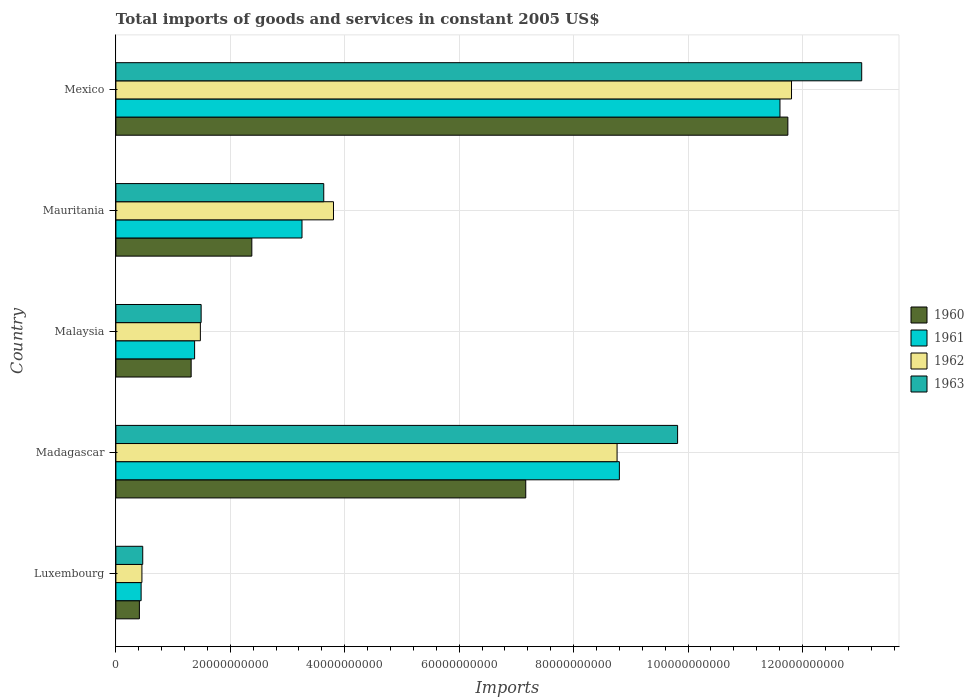How many groups of bars are there?
Ensure brevity in your answer.  5. Are the number of bars on each tick of the Y-axis equal?
Offer a very short reply. Yes. How many bars are there on the 3rd tick from the top?
Offer a terse response. 4. How many bars are there on the 1st tick from the bottom?
Offer a terse response. 4. What is the label of the 5th group of bars from the top?
Your answer should be compact. Luxembourg. In how many cases, is the number of bars for a given country not equal to the number of legend labels?
Provide a short and direct response. 0. What is the total imports of goods and services in 1960 in Malaysia?
Offer a terse response. 1.32e+1. Across all countries, what is the maximum total imports of goods and services in 1960?
Offer a very short reply. 1.17e+11. Across all countries, what is the minimum total imports of goods and services in 1963?
Give a very brief answer. 4.69e+09. In which country was the total imports of goods and services in 1963 minimum?
Provide a short and direct response. Luxembourg. What is the total total imports of goods and services in 1963 in the graph?
Make the answer very short. 2.84e+11. What is the difference between the total imports of goods and services in 1962 in Luxembourg and that in Malaysia?
Your answer should be very brief. -1.02e+1. What is the difference between the total imports of goods and services in 1961 in Mauritania and the total imports of goods and services in 1963 in Luxembourg?
Offer a terse response. 2.78e+1. What is the average total imports of goods and services in 1963 per country?
Ensure brevity in your answer.  5.69e+1. What is the difference between the total imports of goods and services in 1961 and total imports of goods and services in 1962 in Luxembourg?
Provide a short and direct response. -1.40e+08. What is the ratio of the total imports of goods and services in 1962 in Madagascar to that in Malaysia?
Provide a short and direct response. 5.93. Is the difference between the total imports of goods and services in 1961 in Luxembourg and Mexico greater than the difference between the total imports of goods and services in 1962 in Luxembourg and Mexico?
Give a very brief answer. Yes. What is the difference between the highest and the second highest total imports of goods and services in 1963?
Offer a very short reply. 3.22e+1. What is the difference between the highest and the lowest total imports of goods and services in 1962?
Provide a succinct answer. 1.14e+11. In how many countries, is the total imports of goods and services in 1963 greater than the average total imports of goods and services in 1963 taken over all countries?
Provide a succinct answer. 2. What does the 4th bar from the top in Mexico represents?
Offer a terse response. 1960. Are all the bars in the graph horizontal?
Your response must be concise. Yes. What is the difference between two consecutive major ticks on the X-axis?
Provide a short and direct response. 2.00e+1. Are the values on the major ticks of X-axis written in scientific E-notation?
Give a very brief answer. No. Where does the legend appear in the graph?
Ensure brevity in your answer.  Center right. What is the title of the graph?
Offer a very short reply. Total imports of goods and services in constant 2005 US$. Does "2001" appear as one of the legend labels in the graph?
Offer a terse response. No. What is the label or title of the X-axis?
Offer a very short reply. Imports. What is the Imports of 1960 in Luxembourg?
Keep it short and to the point. 4.11e+09. What is the Imports in 1961 in Luxembourg?
Give a very brief answer. 4.41e+09. What is the Imports of 1962 in Luxembourg?
Your answer should be compact. 4.55e+09. What is the Imports in 1963 in Luxembourg?
Make the answer very short. 4.69e+09. What is the Imports of 1960 in Madagascar?
Your answer should be compact. 7.16e+1. What is the Imports of 1961 in Madagascar?
Your response must be concise. 8.80e+1. What is the Imports in 1962 in Madagascar?
Provide a short and direct response. 8.76e+1. What is the Imports of 1963 in Madagascar?
Your response must be concise. 9.82e+1. What is the Imports of 1960 in Malaysia?
Ensure brevity in your answer.  1.32e+1. What is the Imports in 1961 in Malaysia?
Give a very brief answer. 1.38e+1. What is the Imports in 1962 in Malaysia?
Offer a terse response. 1.48e+1. What is the Imports of 1963 in Malaysia?
Your answer should be compact. 1.49e+1. What is the Imports in 1960 in Mauritania?
Offer a terse response. 2.38e+1. What is the Imports in 1961 in Mauritania?
Your answer should be compact. 3.25e+1. What is the Imports in 1962 in Mauritania?
Give a very brief answer. 3.80e+1. What is the Imports of 1963 in Mauritania?
Your answer should be compact. 3.63e+1. What is the Imports of 1960 in Mexico?
Keep it short and to the point. 1.17e+11. What is the Imports of 1961 in Mexico?
Make the answer very short. 1.16e+11. What is the Imports in 1962 in Mexico?
Give a very brief answer. 1.18e+11. What is the Imports of 1963 in Mexico?
Your answer should be very brief. 1.30e+11. Across all countries, what is the maximum Imports in 1960?
Your response must be concise. 1.17e+11. Across all countries, what is the maximum Imports of 1961?
Your response must be concise. 1.16e+11. Across all countries, what is the maximum Imports of 1962?
Offer a terse response. 1.18e+11. Across all countries, what is the maximum Imports of 1963?
Your answer should be very brief. 1.30e+11. Across all countries, what is the minimum Imports of 1960?
Your response must be concise. 4.11e+09. Across all countries, what is the minimum Imports in 1961?
Keep it short and to the point. 4.41e+09. Across all countries, what is the minimum Imports in 1962?
Your answer should be very brief. 4.55e+09. Across all countries, what is the minimum Imports of 1963?
Give a very brief answer. 4.69e+09. What is the total Imports of 1960 in the graph?
Your answer should be very brief. 2.30e+11. What is the total Imports of 1961 in the graph?
Keep it short and to the point. 2.55e+11. What is the total Imports in 1962 in the graph?
Give a very brief answer. 2.63e+11. What is the total Imports of 1963 in the graph?
Make the answer very short. 2.84e+11. What is the difference between the Imports of 1960 in Luxembourg and that in Madagascar?
Your answer should be very brief. -6.75e+1. What is the difference between the Imports of 1961 in Luxembourg and that in Madagascar?
Provide a short and direct response. -8.36e+1. What is the difference between the Imports in 1962 in Luxembourg and that in Madagascar?
Ensure brevity in your answer.  -8.31e+1. What is the difference between the Imports in 1963 in Luxembourg and that in Madagascar?
Keep it short and to the point. -9.35e+1. What is the difference between the Imports in 1960 in Luxembourg and that in Malaysia?
Make the answer very short. -9.05e+09. What is the difference between the Imports of 1961 in Luxembourg and that in Malaysia?
Offer a very short reply. -9.35e+09. What is the difference between the Imports in 1962 in Luxembourg and that in Malaysia?
Keep it short and to the point. -1.02e+1. What is the difference between the Imports in 1963 in Luxembourg and that in Malaysia?
Provide a succinct answer. -1.02e+1. What is the difference between the Imports of 1960 in Luxembourg and that in Mauritania?
Provide a short and direct response. -1.96e+1. What is the difference between the Imports in 1961 in Luxembourg and that in Mauritania?
Give a very brief answer. -2.81e+1. What is the difference between the Imports of 1962 in Luxembourg and that in Mauritania?
Give a very brief answer. -3.35e+1. What is the difference between the Imports in 1963 in Luxembourg and that in Mauritania?
Give a very brief answer. -3.16e+1. What is the difference between the Imports in 1960 in Luxembourg and that in Mexico?
Ensure brevity in your answer.  -1.13e+11. What is the difference between the Imports of 1961 in Luxembourg and that in Mexico?
Your response must be concise. -1.12e+11. What is the difference between the Imports of 1962 in Luxembourg and that in Mexico?
Offer a terse response. -1.14e+11. What is the difference between the Imports of 1963 in Luxembourg and that in Mexico?
Provide a short and direct response. -1.26e+11. What is the difference between the Imports in 1960 in Madagascar and that in Malaysia?
Offer a terse response. 5.85e+1. What is the difference between the Imports in 1961 in Madagascar and that in Malaysia?
Offer a terse response. 7.42e+1. What is the difference between the Imports in 1962 in Madagascar and that in Malaysia?
Make the answer very short. 7.28e+1. What is the difference between the Imports of 1963 in Madagascar and that in Malaysia?
Provide a succinct answer. 8.33e+1. What is the difference between the Imports in 1960 in Madagascar and that in Mauritania?
Your answer should be compact. 4.79e+1. What is the difference between the Imports of 1961 in Madagascar and that in Mauritania?
Your answer should be very brief. 5.55e+1. What is the difference between the Imports in 1962 in Madagascar and that in Mauritania?
Give a very brief answer. 4.96e+1. What is the difference between the Imports in 1963 in Madagascar and that in Mauritania?
Give a very brief answer. 6.18e+1. What is the difference between the Imports of 1960 in Madagascar and that in Mexico?
Your response must be concise. -4.58e+1. What is the difference between the Imports in 1961 in Madagascar and that in Mexico?
Provide a succinct answer. -2.81e+1. What is the difference between the Imports of 1962 in Madagascar and that in Mexico?
Offer a terse response. -3.05e+1. What is the difference between the Imports in 1963 in Madagascar and that in Mexico?
Provide a succinct answer. -3.22e+1. What is the difference between the Imports in 1960 in Malaysia and that in Mauritania?
Ensure brevity in your answer.  -1.06e+1. What is the difference between the Imports in 1961 in Malaysia and that in Mauritania?
Your answer should be compact. -1.88e+1. What is the difference between the Imports of 1962 in Malaysia and that in Mauritania?
Your response must be concise. -2.33e+1. What is the difference between the Imports in 1963 in Malaysia and that in Mauritania?
Offer a terse response. -2.14e+1. What is the difference between the Imports of 1960 in Malaysia and that in Mexico?
Your response must be concise. -1.04e+11. What is the difference between the Imports of 1961 in Malaysia and that in Mexico?
Ensure brevity in your answer.  -1.02e+11. What is the difference between the Imports in 1962 in Malaysia and that in Mexico?
Provide a succinct answer. -1.03e+11. What is the difference between the Imports in 1963 in Malaysia and that in Mexico?
Offer a very short reply. -1.15e+11. What is the difference between the Imports of 1960 in Mauritania and that in Mexico?
Give a very brief answer. -9.37e+1. What is the difference between the Imports of 1961 in Mauritania and that in Mexico?
Your answer should be very brief. -8.35e+1. What is the difference between the Imports in 1962 in Mauritania and that in Mexico?
Ensure brevity in your answer.  -8.01e+1. What is the difference between the Imports in 1963 in Mauritania and that in Mexico?
Your response must be concise. -9.40e+1. What is the difference between the Imports of 1960 in Luxembourg and the Imports of 1961 in Madagascar?
Ensure brevity in your answer.  -8.39e+1. What is the difference between the Imports of 1960 in Luxembourg and the Imports of 1962 in Madagascar?
Keep it short and to the point. -8.35e+1. What is the difference between the Imports in 1960 in Luxembourg and the Imports in 1963 in Madagascar?
Provide a succinct answer. -9.41e+1. What is the difference between the Imports in 1961 in Luxembourg and the Imports in 1962 in Madagascar?
Provide a succinct answer. -8.32e+1. What is the difference between the Imports in 1961 in Luxembourg and the Imports in 1963 in Madagascar?
Ensure brevity in your answer.  -9.38e+1. What is the difference between the Imports of 1962 in Luxembourg and the Imports of 1963 in Madagascar?
Your answer should be compact. -9.36e+1. What is the difference between the Imports in 1960 in Luxembourg and the Imports in 1961 in Malaysia?
Keep it short and to the point. -9.65e+09. What is the difference between the Imports in 1960 in Luxembourg and the Imports in 1962 in Malaysia?
Your answer should be compact. -1.07e+1. What is the difference between the Imports in 1960 in Luxembourg and the Imports in 1963 in Malaysia?
Give a very brief answer. -1.08e+1. What is the difference between the Imports in 1961 in Luxembourg and the Imports in 1962 in Malaysia?
Offer a very short reply. -1.04e+1. What is the difference between the Imports of 1961 in Luxembourg and the Imports of 1963 in Malaysia?
Your response must be concise. -1.05e+1. What is the difference between the Imports in 1962 in Luxembourg and the Imports in 1963 in Malaysia?
Your answer should be compact. -1.03e+1. What is the difference between the Imports of 1960 in Luxembourg and the Imports of 1961 in Mauritania?
Offer a very short reply. -2.84e+1. What is the difference between the Imports of 1960 in Luxembourg and the Imports of 1962 in Mauritania?
Give a very brief answer. -3.39e+1. What is the difference between the Imports of 1960 in Luxembourg and the Imports of 1963 in Mauritania?
Keep it short and to the point. -3.22e+1. What is the difference between the Imports in 1961 in Luxembourg and the Imports in 1962 in Mauritania?
Give a very brief answer. -3.36e+1. What is the difference between the Imports of 1961 in Luxembourg and the Imports of 1963 in Mauritania?
Offer a terse response. -3.19e+1. What is the difference between the Imports of 1962 in Luxembourg and the Imports of 1963 in Mauritania?
Your answer should be compact. -3.18e+1. What is the difference between the Imports of 1960 in Luxembourg and the Imports of 1961 in Mexico?
Provide a short and direct response. -1.12e+11. What is the difference between the Imports of 1960 in Luxembourg and the Imports of 1962 in Mexico?
Make the answer very short. -1.14e+11. What is the difference between the Imports of 1960 in Luxembourg and the Imports of 1963 in Mexico?
Your response must be concise. -1.26e+11. What is the difference between the Imports in 1961 in Luxembourg and the Imports in 1962 in Mexico?
Offer a very short reply. -1.14e+11. What is the difference between the Imports of 1961 in Luxembourg and the Imports of 1963 in Mexico?
Give a very brief answer. -1.26e+11. What is the difference between the Imports of 1962 in Luxembourg and the Imports of 1963 in Mexico?
Offer a terse response. -1.26e+11. What is the difference between the Imports of 1960 in Madagascar and the Imports of 1961 in Malaysia?
Your answer should be compact. 5.79e+1. What is the difference between the Imports of 1960 in Madagascar and the Imports of 1962 in Malaysia?
Your answer should be compact. 5.69e+1. What is the difference between the Imports of 1960 in Madagascar and the Imports of 1963 in Malaysia?
Offer a very short reply. 5.67e+1. What is the difference between the Imports of 1961 in Madagascar and the Imports of 1962 in Malaysia?
Ensure brevity in your answer.  7.32e+1. What is the difference between the Imports of 1961 in Madagascar and the Imports of 1963 in Malaysia?
Provide a succinct answer. 7.31e+1. What is the difference between the Imports of 1962 in Madagascar and the Imports of 1963 in Malaysia?
Offer a very short reply. 7.27e+1. What is the difference between the Imports in 1960 in Madagascar and the Imports in 1961 in Mauritania?
Give a very brief answer. 3.91e+1. What is the difference between the Imports of 1960 in Madagascar and the Imports of 1962 in Mauritania?
Your response must be concise. 3.36e+1. What is the difference between the Imports in 1960 in Madagascar and the Imports in 1963 in Mauritania?
Your answer should be very brief. 3.53e+1. What is the difference between the Imports in 1961 in Madagascar and the Imports in 1962 in Mauritania?
Your answer should be very brief. 5.00e+1. What is the difference between the Imports of 1961 in Madagascar and the Imports of 1963 in Mauritania?
Give a very brief answer. 5.17e+1. What is the difference between the Imports of 1962 in Madagascar and the Imports of 1963 in Mauritania?
Offer a very short reply. 5.13e+1. What is the difference between the Imports of 1960 in Madagascar and the Imports of 1961 in Mexico?
Make the answer very short. -4.44e+1. What is the difference between the Imports of 1960 in Madagascar and the Imports of 1962 in Mexico?
Your answer should be compact. -4.65e+1. What is the difference between the Imports in 1960 in Madagascar and the Imports in 1963 in Mexico?
Offer a very short reply. -5.87e+1. What is the difference between the Imports of 1961 in Madagascar and the Imports of 1962 in Mexico?
Provide a short and direct response. -3.01e+1. What is the difference between the Imports of 1961 in Madagascar and the Imports of 1963 in Mexico?
Keep it short and to the point. -4.24e+1. What is the difference between the Imports in 1962 in Madagascar and the Imports in 1963 in Mexico?
Keep it short and to the point. -4.28e+1. What is the difference between the Imports of 1960 in Malaysia and the Imports of 1961 in Mauritania?
Ensure brevity in your answer.  -1.94e+1. What is the difference between the Imports of 1960 in Malaysia and the Imports of 1962 in Mauritania?
Provide a short and direct response. -2.49e+1. What is the difference between the Imports of 1960 in Malaysia and the Imports of 1963 in Mauritania?
Make the answer very short. -2.32e+1. What is the difference between the Imports of 1961 in Malaysia and the Imports of 1962 in Mauritania?
Your answer should be very brief. -2.43e+1. What is the difference between the Imports in 1961 in Malaysia and the Imports in 1963 in Mauritania?
Give a very brief answer. -2.26e+1. What is the difference between the Imports in 1962 in Malaysia and the Imports in 1963 in Mauritania?
Make the answer very short. -2.16e+1. What is the difference between the Imports of 1960 in Malaysia and the Imports of 1961 in Mexico?
Your answer should be compact. -1.03e+11. What is the difference between the Imports in 1960 in Malaysia and the Imports in 1962 in Mexico?
Provide a short and direct response. -1.05e+11. What is the difference between the Imports of 1960 in Malaysia and the Imports of 1963 in Mexico?
Give a very brief answer. -1.17e+11. What is the difference between the Imports in 1961 in Malaysia and the Imports in 1962 in Mexico?
Your answer should be very brief. -1.04e+11. What is the difference between the Imports of 1961 in Malaysia and the Imports of 1963 in Mexico?
Your response must be concise. -1.17e+11. What is the difference between the Imports of 1962 in Malaysia and the Imports of 1963 in Mexico?
Give a very brief answer. -1.16e+11. What is the difference between the Imports of 1960 in Mauritania and the Imports of 1961 in Mexico?
Provide a short and direct response. -9.23e+1. What is the difference between the Imports of 1960 in Mauritania and the Imports of 1962 in Mexico?
Your response must be concise. -9.43e+1. What is the difference between the Imports of 1960 in Mauritania and the Imports of 1963 in Mexico?
Give a very brief answer. -1.07e+11. What is the difference between the Imports of 1961 in Mauritania and the Imports of 1962 in Mexico?
Offer a terse response. -8.56e+1. What is the difference between the Imports of 1961 in Mauritania and the Imports of 1963 in Mexico?
Provide a succinct answer. -9.78e+1. What is the difference between the Imports in 1962 in Mauritania and the Imports in 1963 in Mexico?
Your answer should be very brief. -9.23e+1. What is the average Imports of 1960 per country?
Ensure brevity in your answer.  4.60e+1. What is the average Imports of 1961 per country?
Provide a short and direct response. 5.10e+1. What is the average Imports in 1962 per country?
Give a very brief answer. 5.26e+1. What is the average Imports in 1963 per country?
Give a very brief answer. 5.69e+1. What is the difference between the Imports of 1960 and Imports of 1961 in Luxembourg?
Keep it short and to the point. -3.01e+08. What is the difference between the Imports of 1960 and Imports of 1962 in Luxembourg?
Your answer should be compact. -4.41e+08. What is the difference between the Imports of 1960 and Imports of 1963 in Luxembourg?
Offer a very short reply. -5.83e+08. What is the difference between the Imports of 1961 and Imports of 1962 in Luxembourg?
Your answer should be compact. -1.40e+08. What is the difference between the Imports in 1961 and Imports in 1963 in Luxembourg?
Offer a terse response. -2.82e+08. What is the difference between the Imports in 1962 and Imports in 1963 in Luxembourg?
Your answer should be very brief. -1.42e+08. What is the difference between the Imports in 1960 and Imports in 1961 in Madagascar?
Your response must be concise. -1.64e+1. What is the difference between the Imports in 1960 and Imports in 1962 in Madagascar?
Give a very brief answer. -1.60e+1. What is the difference between the Imports of 1960 and Imports of 1963 in Madagascar?
Your response must be concise. -2.65e+1. What is the difference between the Imports of 1961 and Imports of 1962 in Madagascar?
Your answer should be compact. 3.99e+08. What is the difference between the Imports of 1961 and Imports of 1963 in Madagascar?
Offer a very short reply. -1.02e+1. What is the difference between the Imports in 1962 and Imports in 1963 in Madagascar?
Your response must be concise. -1.06e+1. What is the difference between the Imports of 1960 and Imports of 1961 in Malaysia?
Keep it short and to the point. -6.03e+08. What is the difference between the Imports of 1960 and Imports of 1962 in Malaysia?
Keep it short and to the point. -1.61e+09. What is the difference between the Imports in 1960 and Imports in 1963 in Malaysia?
Make the answer very short. -1.74e+09. What is the difference between the Imports of 1961 and Imports of 1962 in Malaysia?
Provide a short and direct response. -1.01e+09. What is the difference between the Imports in 1961 and Imports in 1963 in Malaysia?
Offer a terse response. -1.14e+09. What is the difference between the Imports in 1962 and Imports in 1963 in Malaysia?
Provide a succinct answer. -1.35e+08. What is the difference between the Imports in 1960 and Imports in 1961 in Mauritania?
Offer a very short reply. -8.77e+09. What is the difference between the Imports in 1960 and Imports in 1962 in Mauritania?
Offer a very short reply. -1.43e+1. What is the difference between the Imports of 1960 and Imports of 1963 in Mauritania?
Offer a terse response. -1.26e+1. What is the difference between the Imports in 1961 and Imports in 1962 in Mauritania?
Give a very brief answer. -5.50e+09. What is the difference between the Imports of 1961 and Imports of 1963 in Mauritania?
Offer a terse response. -3.80e+09. What is the difference between the Imports in 1962 and Imports in 1963 in Mauritania?
Keep it short and to the point. 1.70e+09. What is the difference between the Imports in 1960 and Imports in 1961 in Mexico?
Provide a succinct answer. 1.38e+09. What is the difference between the Imports of 1960 and Imports of 1962 in Mexico?
Your response must be concise. -6.38e+08. What is the difference between the Imports of 1960 and Imports of 1963 in Mexico?
Keep it short and to the point. -1.29e+1. What is the difference between the Imports of 1961 and Imports of 1962 in Mexico?
Provide a succinct answer. -2.02e+09. What is the difference between the Imports in 1961 and Imports in 1963 in Mexico?
Your answer should be compact. -1.43e+1. What is the difference between the Imports in 1962 and Imports in 1963 in Mexico?
Provide a succinct answer. -1.23e+1. What is the ratio of the Imports of 1960 in Luxembourg to that in Madagascar?
Give a very brief answer. 0.06. What is the ratio of the Imports of 1961 in Luxembourg to that in Madagascar?
Your response must be concise. 0.05. What is the ratio of the Imports in 1962 in Luxembourg to that in Madagascar?
Your answer should be compact. 0.05. What is the ratio of the Imports of 1963 in Luxembourg to that in Madagascar?
Give a very brief answer. 0.05. What is the ratio of the Imports of 1960 in Luxembourg to that in Malaysia?
Your answer should be very brief. 0.31. What is the ratio of the Imports in 1961 in Luxembourg to that in Malaysia?
Ensure brevity in your answer.  0.32. What is the ratio of the Imports of 1962 in Luxembourg to that in Malaysia?
Keep it short and to the point. 0.31. What is the ratio of the Imports in 1963 in Luxembourg to that in Malaysia?
Provide a succinct answer. 0.31. What is the ratio of the Imports in 1960 in Luxembourg to that in Mauritania?
Offer a very short reply. 0.17. What is the ratio of the Imports of 1961 in Luxembourg to that in Mauritania?
Your answer should be compact. 0.14. What is the ratio of the Imports of 1962 in Luxembourg to that in Mauritania?
Ensure brevity in your answer.  0.12. What is the ratio of the Imports in 1963 in Luxembourg to that in Mauritania?
Make the answer very short. 0.13. What is the ratio of the Imports in 1960 in Luxembourg to that in Mexico?
Keep it short and to the point. 0.04. What is the ratio of the Imports in 1961 in Luxembourg to that in Mexico?
Your answer should be very brief. 0.04. What is the ratio of the Imports in 1962 in Luxembourg to that in Mexico?
Keep it short and to the point. 0.04. What is the ratio of the Imports in 1963 in Luxembourg to that in Mexico?
Offer a very short reply. 0.04. What is the ratio of the Imports in 1960 in Madagascar to that in Malaysia?
Provide a succinct answer. 5.45. What is the ratio of the Imports of 1961 in Madagascar to that in Malaysia?
Provide a succinct answer. 6.4. What is the ratio of the Imports of 1962 in Madagascar to that in Malaysia?
Your answer should be compact. 5.93. What is the ratio of the Imports in 1963 in Madagascar to that in Malaysia?
Your answer should be very brief. 6.59. What is the ratio of the Imports in 1960 in Madagascar to that in Mauritania?
Keep it short and to the point. 3.02. What is the ratio of the Imports in 1961 in Madagascar to that in Mauritania?
Provide a short and direct response. 2.71. What is the ratio of the Imports in 1962 in Madagascar to that in Mauritania?
Your answer should be compact. 2.3. What is the ratio of the Imports of 1963 in Madagascar to that in Mauritania?
Offer a terse response. 2.7. What is the ratio of the Imports of 1960 in Madagascar to that in Mexico?
Offer a very short reply. 0.61. What is the ratio of the Imports of 1961 in Madagascar to that in Mexico?
Give a very brief answer. 0.76. What is the ratio of the Imports of 1962 in Madagascar to that in Mexico?
Offer a very short reply. 0.74. What is the ratio of the Imports of 1963 in Madagascar to that in Mexico?
Offer a terse response. 0.75. What is the ratio of the Imports of 1960 in Malaysia to that in Mauritania?
Your response must be concise. 0.55. What is the ratio of the Imports in 1961 in Malaysia to that in Mauritania?
Your response must be concise. 0.42. What is the ratio of the Imports of 1962 in Malaysia to that in Mauritania?
Offer a very short reply. 0.39. What is the ratio of the Imports in 1963 in Malaysia to that in Mauritania?
Make the answer very short. 0.41. What is the ratio of the Imports in 1960 in Malaysia to that in Mexico?
Offer a terse response. 0.11. What is the ratio of the Imports of 1961 in Malaysia to that in Mexico?
Provide a short and direct response. 0.12. What is the ratio of the Imports in 1963 in Malaysia to that in Mexico?
Offer a very short reply. 0.11. What is the ratio of the Imports of 1960 in Mauritania to that in Mexico?
Offer a very short reply. 0.2. What is the ratio of the Imports in 1961 in Mauritania to that in Mexico?
Provide a short and direct response. 0.28. What is the ratio of the Imports in 1962 in Mauritania to that in Mexico?
Offer a very short reply. 0.32. What is the ratio of the Imports of 1963 in Mauritania to that in Mexico?
Provide a short and direct response. 0.28. What is the difference between the highest and the second highest Imports in 1960?
Ensure brevity in your answer.  4.58e+1. What is the difference between the highest and the second highest Imports in 1961?
Your answer should be very brief. 2.81e+1. What is the difference between the highest and the second highest Imports of 1962?
Ensure brevity in your answer.  3.05e+1. What is the difference between the highest and the second highest Imports in 1963?
Provide a succinct answer. 3.22e+1. What is the difference between the highest and the lowest Imports in 1960?
Offer a very short reply. 1.13e+11. What is the difference between the highest and the lowest Imports of 1961?
Keep it short and to the point. 1.12e+11. What is the difference between the highest and the lowest Imports of 1962?
Ensure brevity in your answer.  1.14e+11. What is the difference between the highest and the lowest Imports in 1963?
Provide a succinct answer. 1.26e+11. 